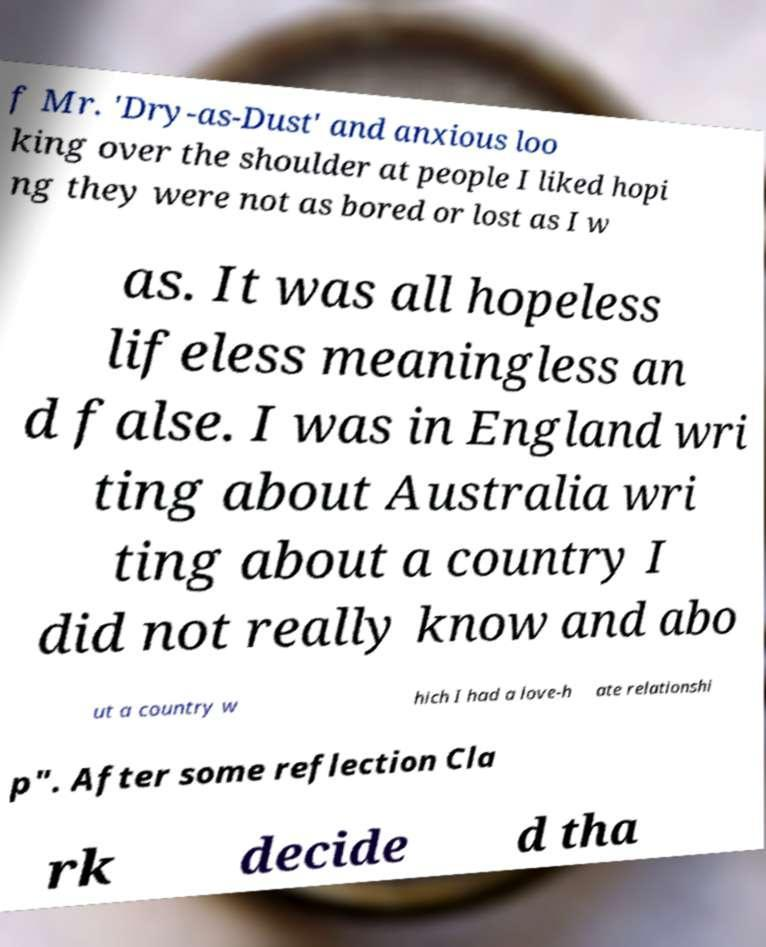Can you read and provide the text displayed in the image?This photo seems to have some interesting text. Can you extract and type it out for me? f Mr. 'Dry-as-Dust' and anxious loo king over the shoulder at people I liked hopi ng they were not as bored or lost as I w as. It was all hopeless lifeless meaningless an d false. I was in England wri ting about Australia wri ting about a country I did not really know and abo ut a country w hich I had a love-h ate relationshi p". After some reflection Cla rk decide d tha 